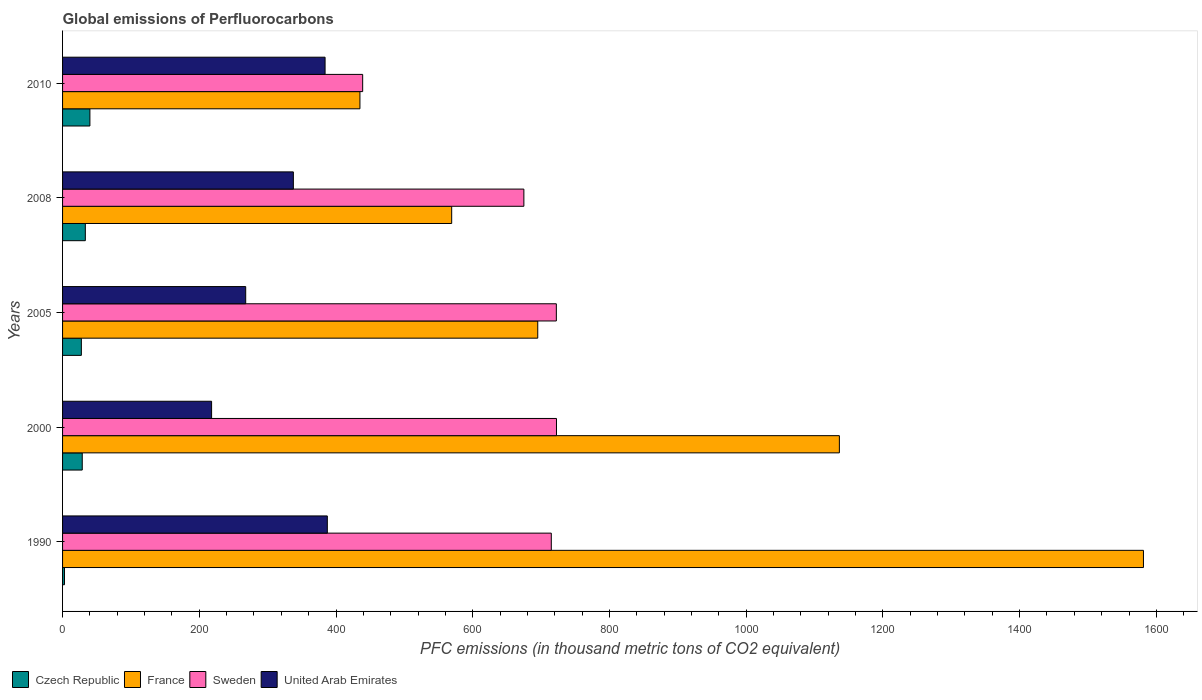How many different coloured bars are there?
Offer a very short reply. 4. How many groups of bars are there?
Give a very brief answer. 5. How many bars are there on the 4th tick from the top?
Offer a terse response. 4. What is the global emissions of Perfluorocarbons in Czech Republic in 2008?
Ensure brevity in your answer.  33.3. Across all years, what is the minimum global emissions of Perfluorocarbons in United Arab Emirates?
Your answer should be very brief. 218. What is the total global emissions of Perfluorocarbons in United Arab Emirates in the graph?
Ensure brevity in your answer.  1594.8. What is the difference between the global emissions of Perfluorocarbons in France in 1990 and that in 2005?
Offer a very short reply. 886. What is the difference between the global emissions of Perfluorocarbons in Sweden in 1990 and the global emissions of Perfluorocarbons in Czech Republic in 2005?
Your answer should be compact. 687.4. What is the average global emissions of Perfluorocarbons in Czech Republic per year?
Offer a terse response. 26.48. In the year 1990, what is the difference between the global emissions of Perfluorocarbons in Sweden and global emissions of Perfluorocarbons in Czech Republic?
Provide a short and direct response. 712.1. In how many years, is the global emissions of Perfluorocarbons in Czech Republic greater than 440 thousand metric tons?
Your answer should be very brief. 0. What is the ratio of the global emissions of Perfluorocarbons in United Arab Emirates in 2005 to that in 2008?
Your response must be concise. 0.79. Is the global emissions of Perfluorocarbons in Sweden in 1990 less than that in 2005?
Provide a succinct answer. Yes. Is the difference between the global emissions of Perfluorocarbons in Sweden in 1990 and 2000 greater than the difference between the global emissions of Perfluorocarbons in Czech Republic in 1990 and 2000?
Make the answer very short. Yes. What is the difference between the highest and the second highest global emissions of Perfluorocarbons in France?
Offer a terse response. 444.8. What is the difference between the highest and the lowest global emissions of Perfluorocarbons in United Arab Emirates?
Give a very brief answer. 169.3. Is it the case that in every year, the sum of the global emissions of Perfluorocarbons in Sweden and global emissions of Perfluorocarbons in Czech Republic is greater than the sum of global emissions of Perfluorocarbons in United Arab Emirates and global emissions of Perfluorocarbons in France?
Give a very brief answer. Yes. What does the 2nd bar from the top in 2005 represents?
Ensure brevity in your answer.  Sweden. What does the 4th bar from the bottom in 2005 represents?
Your answer should be compact. United Arab Emirates. Is it the case that in every year, the sum of the global emissions of Perfluorocarbons in Sweden and global emissions of Perfluorocarbons in United Arab Emirates is greater than the global emissions of Perfluorocarbons in France?
Keep it short and to the point. No. How many bars are there?
Keep it short and to the point. 20. Does the graph contain any zero values?
Your answer should be very brief. No. Does the graph contain grids?
Ensure brevity in your answer.  No. Where does the legend appear in the graph?
Provide a short and direct response. Bottom left. How many legend labels are there?
Your answer should be very brief. 4. How are the legend labels stacked?
Your answer should be very brief. Horizontal. What is the title of the graph?
Your response must be concise. Global emissions of Perfluorocarbons. Does "Papua New Guinea" appear as one of the legend labels in the graph?
Keep it short and to the point. No. What is the label or title of the X-axis?
Your response must be concise. PFC emissions (in thousand metric tons of CO2 equivalent). What is the PFC emissions (in thousand metric tons of CO2 equivalent) of France in 1990?
Offer a very short reply. 1581.1. What is the PFC emissions (in thousand metric tons of CO2 equivalent) of Sweden in 1990?
Ensure brevity in your answer.  714.9. What is the PFC emissions (in thousand metric tons of CO2 equivalent) in United Arab Emirates in 1990?
Your answer should be very brief. 387.3. What is the PFC emissions (in thousand metric tons of CO2 equivalent) of Czech Republic in 2000?
Offer a terse response. 28.8. What is the PFC emissions (in thousand metric tons of CO2 equivalent) in France in 2000?
Give a very brief answer. 1136.3. What is the PFC emissions (in thousand metric tons of CO2 equivalent) of Sweden in 2000?
Keep it short and to the point. 722.5. What is the PFC emissions (in thousand metric tons of CO2 equivalent) of United Arab Emirates in 2000?
Your response must be concise. 218. What is the PFC emissions (in thousand metric tons of CO2 equivalent) in France in 2005?
Offer a terse response. 695.1. What is the PFC emissions (in thousand metric tons of CO2 equivalent) in Sweden in 2005?
Offer a terse response. 722.3. What is the PFC emissions (in thousand metric tons of CO2 equivalent) of United Arab Emirates in 2005?
Your answer should be compact. 267.9. What is the PFC emissions (in thousand metric tons of CO2 equivalent) of Czech Republic in 2008?
Your answer should be compact. 33.3. What is the PFC emissions (in thousand metric tons of CO2 equivalent) in France in 2008?
Give a very brief answer. 569.2. What is the PFC emissions (in thousand metric tons of CO2 equivalent) of Sweden in 2008?
Offer a terse response. 674.8. What is the PFC emissions (in thousand metric tons of CO2 equivalent) in United Arab Emirates in 2008?
Provide a succinct answer. 337.6. What is the PFC emissions (in thousand metric tons of CO2 equivalent) in Czech Republic in 2010?
Your response must be concise. 40. What is the PFC emissions (in thousand metric tons of CO2 equivalent) of France in 2010?
Your response must be concise. 435. What is the PFC emissions (in thousand metric tons of CO2 equivalent) of Sweden in 2010?
Ensure brevity in your answer.  439. What is the PFC emissions (in thousand metric tons of CO2 equivalent) of United Arab Emirates in 2010?
Give a very brief answer. 384. Across all years, what is the maximum PFC emissions (in thousand metric tons of CO2 equivalent) of Czech Republic?
Your answer should be compact. 40. Across all years, what is the maximum PFC emissions (in thousand metric tons of CO2 equivalent) of France?
Make the answer very short. 1581.1. Across all years, what is the maximum PFC emissions (in thousand metric tons of CO2 equivalent) of Sweden?
Provide a succinct answer. 722.5. Across all years, what is the maximum PFC emissions (in thousand metric tons of CO2 equivalent) in United Arab Emirates?
Provide a succinct answer. 387.3. Across all years, what is the minimum PFC emissions (in thousand metric tons of CO2 equivalent) in Czech Republic?
Your answer should be compact. 2.8. Across all years, what is the minimum PFC emissions (in thousand metric tons of CO2 equivalent) of France?
Provide a succinct answer. 435. Across all years, what is the minimum PFC emissions (in thousand metric tons of CO2 equivalent) in Sweden?
Your response must be concise. 439. Across all years, what is the minimum PFC emissions (in thousand metric tons of CO2 equivalent) of United Arab Emirates?
Provide a short and direct response. 218. What is the total PFC emissions (in thousand metric tons of CO2 equivalent) in Czech Republic in the graph?
Your response must be concise. 132.4. What is the total PFC emissions (in thousand metric tons of CO2 equivalent) of France in the graph?
Offer a very short reply. 4416.7. What is the total PFC emissions (in thousand metric tons of CO2 equivalent) in Sweden in the graph?
Provide a short and direct response. 3273.5. What is the total PFC emissions (in thousand metric tons of CO2 equivalent) in United Arab Emirates in the graph?
Give a very brief answer. 1594.8. What is the difference between the PFC emissions (in thousand metric tons of CO2 equivalent) in Czech Republic in 1990 and that in 2000?
Provide a short and direct response. -26. What is the difference between the PFC emissions (in thousand metric tons of CO2 equivalent) of France in 1990 and that in 2000?
Offer a terse response. 444.8. What is the difference between the PFC emissions (in thousand metric tons of CO2 equivalent) of United Arab Emirates in 1990 and that in 2000?
Give a very brief answer. 169.3. What is the difference between the PFC emissions (in thousand metric tons of CO2 equivalent) of Czech Republic in 1990 and that in 2005?
Offer a terse response. -24.7. What is the difference between the PFC emissions (in thousand metric tons of CO2 equivalent) in France in 1990 and that in 2005?
Keep it short and to the point. 886. What is the difference between the PFC emissions (in thousand metric tons of CO2 equivalent) in United Arab Emirates in 1990 and that in 2005?
Your answer should be compact. 119.4. What is the difference between the PFC emissions (in thousand metric tons of CO2 equivalent) in Czech Republic in 1990 and that in 2008?
Provide a succinct answer. -30.5. What is the difference between the PFC emissions (in thousand metric tons of CO2 equivalent) of France in 1990 and that in 2008?
Your answer should be very brief. 1011.9. What is the difference between the PFC emissions (in thousand metric tons of CO2 equivalent) of Sweden in 1990 and that in 2008?
Give a very brief answer. 40.1. What is the difference between the PFC emissions (in thousand metric tons of CO2 equivalent) in United Arab Emirates in 1990 and that in 2008?
Provide a short and direct response. 49.7. What is the difference between the PFC emissions (in thousand metric tons of CO2 equivalent) of Czech Republic in 1990 and that in 2010?
Provide a short and direct response. -37.2. What is the difference between the PFC emissions (in thousand metric tons of CO2 equivalent) of France in 1990 and that in 2010?
Ensure brevity in your answer.  1146.1. What is the difference between the PFC emissions (in thousand metric tons of CO2 equivalent) of Sweden in 1990 and that in 2010?
Your answer should be compact. 275.9. What is the difference between the PFC emissions (in thousand metric tons of CO2 equivalent) of Czech Republic in 2000 and that in 2005?
Your response must be concise. 1.3. What is the difference between the PFC emissions (in thousand metric tons of CO2 equivalent) in France in 2000 and that in 2005?
Provide a short and direct response. 441.2. What is the difference between the PFC emissions (in thousand metric tons of CO2 equivalent) in United Arab Emirates in 2000 and that in 2005?
Your response must be concise. -49.9. What is the difference between the PFC emissions (in thousand metric tons of CO2 equivalent) of France in 2000 and that in 2008?
Ensure brevity in your answer.  567.1. What is the difference between the PFC emissions (in thousand metric tons of CO2 equivalent) in Sweden in 2000 and that in 2008?
Offer a terse response. 47.7. What is the difference between the PFC emissions (in thousand metric tons of CO2 equivalent) of United Arab Emirates in 2000 and that in 2008?
Your response must be concise. -119.6. What is the difference between the PFC emissions (in thousand metric tons of CO2 equivalent) in France in 2000 and that in 2010?
Ensure brevity in your answer.  701.3. What is the difference between the PFC emissions (in thousand metric tons of CO2 equivalent) of Sweden in 2000 and that in 2010?
Your answer should be very brief. 283.5. What is the difference between the PFC emissions (in thousand metric tons of CO2 equivalent) of United Arab Emirates in 2000 and that in 2010?
Make the answer very short. -166. What is the difference between the PFC emissions (in thousand metric tons of CO2 equivalent) in Czech Republic in 2005 and that in 2008?
Ensure brevity in your answer.  -5.8. What is the difference between the PFC emissions (in thousand metric tons of CO2 equivalent) in France in 2005 and that in 2008?
Keep it short and to the point. 125.9. What is the difference between the PFC emissions (in thousand metric tons of CO2 equivalent) of Sweden in 2005 and that in 2008?
Ensure brevity in your answer.  47.5. What is the difference between the PFC emissions (in thousand metric tons of CO2 equivalent) in United Arab Emirates in 2005 and that in 2008?
Your response must be concise. -69.7. What is the difference between the PFC emissions (in thousand metric tons of CO2 equivalent) in Czech Republic in 2005 and that in 2010?
Ensure brevity in your answer.  -12.5. What is the difference between the PFC emissions (in thousand metric tons of CO2 equivalent) in France in 2005 and that in 2010?
Your answer should be compact. 260.1. What is the difference between the PFC emissions (in thousand metric tons of CO2 equivalent) in Sweden in 2005 and that in 2010?
Provide a short and direct response. 283.3. What is the difference between the PFC emissions (in thousand metric tons of CO2 equivalent) of United Arab Emirates in 2005 and that in 2010?
Keep it short and to the point. -116.1. What is the difference between the PFC emissions (in thousand metric tons of CO2 equivalent) in France in 2008 and that in 2010?
Offer a very short reply. 134.2. What is the difference between the PFC emissions (in thousand metric tons of CO2 equivalent) of Sweden in 2008 and that in 2010?
Keep it short and to the point. 235.8. What is the difference between the PFC emissions (in thousand metric tons of CO2 equivalent) of United Arab Emirates in 2008 and that in 2010?
Give a very brief answer. -46.4. What is the difference between the PFC emissions (in thousand metric tons of CO2 equivalent) in Czech Republic in 1990 and the PFC emissions (in thousand metric tons of CO2 equivalent) in France in 2000?
Provide a succinct answer. -1133.5. What is the difference between the PFC emissions (in thousand metric tons of CO2 equivalent) of Czech Republic in 1990 and the PFC emissions (in thousand metric tons of CO2 equivalent) of Sweden in 2000?
Your response must be concise. -719.7. What is the difference between the PFC emissions (in thousand metric tons of CO2 equivalent) in Czech Republic in 1990 and the PFC emissions (in thousand metric tons of CO2 equivalent) in United Arab Emirates in 2000?
Give a very brief answer. -215.2. What is the difference between the PFC emissions (in thousand metric tons of CO2 equivalent) in France in 1990 and the PFC emissions (in thousand metric tons of CO2 equivalent) in Sweden in 2000?
Your response must be concise. 858.6. What is the difference between the PFC emissions (in thousand metric tons of CO2 equivalent) of France in 1990 and the PFC emissions (in thousand metric tons of CO2 equivalent) of United Arab Emirates in 2000?
Offer a very short reply. 1363.1. What is the difference between the PFC emissions (in thousand metric tons of CO2 equivalent) in Sweden in 1990 and the PFC emissions (in thousand metric tons of CO2 equivalent) in United Arab Emirates in 2000?
Give a very brief answer. 496.9. What is the difference between the PFC emissions (in thousand metric tons of CO2 equivalent) of Czech Republic in 1990 and the PFC emissions (in thousand metric tons of CO2 equivalent) of France in 2005?
Your answer should be very brief. -692.3. What is the difference between the PFC emissions (in thousand metric tons of CO2 equivalent) in Czech Republic in 1990 and the PFC emissions (in thousand metric tons of CO2 equivalent) in Sweden in 2005?
Your response must be concise. -719.5. What is the difference between the PFC emissions (in thousand metric tons of CO2 equivalent) of Czech Republic in 1990 and the PFC emissions (in thousand metric tons of CO2 equivalent) of United Arab Emirates in 2005?
Ensure brevity in your answer.  -265.1. What is the difference between the PFC emissions (in thousand metric tons of CO2 equivalent) in France in 1990 and the PFC emissions (in thousand metric tons of CO2 equivalent) in Sweden in 2005?
Your answer should be compact. 858.8. What is the difference between the PFC emissions (in thousand metric tons of CO2 equivalent) of France in 1990 and the PFC emissions (in thousand metric tons of CO2 equivalent) of United Arab Emirates in 2005?
Make the answer very short. 1313.2. What is the difference between the PFC emissions (in thousand metric tons of CO2 equivalent) of Sweden in 1990 and the PFC emissions (in thousand metric tons of CO2 equivalent) of United Arab Emirates in 2005?
Give a very brief answer. 447. What is the difference between the PFC emissions (in thousand metric tons of CO2 equivalent) of Czech Republic in 1990 and the PFC emissions (in thousand metric tons of CO2 equivalent) of France in 2008?
Keep it short and to the point. -566.4. What is the difference between the PFC emissions (in thousand metric tons of CO2 equivalent) of Czech Republic in 1990 and the PFC emissions (in thousand metric tons of CO2 equivalent) of Sweden in 2008?
Ensure brevity in your answer.  -672. What is the difference between the PFC emissions (in thousand metric tons of CO2 equivalent) of Czech Republic in 1990 and the PFC emissions (in thousand metric tons of CO2 equivalent) of United Arab Emirates in 2008?
Your answer should be very brief. -334.8. What is the difference between the PFC emissions (in thousand metric tons of CO2 equivalent) of France in 1990 and the PFC emissions (in thousand metric tons of CO2 equivalent) of Sweden in 2008?
Make the answer very short. 906.3. What is the difference between the PFC emissions (in thousand metric tons of CO2 equivalent) of France in 1990 and the PFC emissions (in thousand metric tons of CO2 equivalent) of United Arab Emirates in 2008?
Your answer should be compact. 1243.5. What is the difference between the PFC emissions (in thousand metric tons of CO2 equivalent) of Sweden in 1990 and the PFC emissions (in thousand metric tons of CO2 equivalent) of United Arab Emirates in 2008?
Keep it short and to the point. 377.3. What is the difference between the PFC emissions (in thousand metric tons of CO2 equivalent) of Czech Republic in 1990 and the PFC emissions (in thousand metric tons of CO2 equivalent) of France in 2010?
Your answer should be very brief. -432.2. What is the difference between the PFC emissions (in thousand metric tons of CO2 equivalent) of Czech Republic in 1990 and the PFC emissions (in thousand metric tons of CO2 equivalent) of Sweden in 2010?
Give a very brief answer. -436.2. What is the difference between the PFC emissions (in thousand metric tons of CO2 equivalent) of Czech Republic in 1990 and the PFC emissions (in thousand metric tons of CO2 equivalent) of United Arab Emirates in 2010?
Offer a very short reply. -381.2. What is the difference between the PFC emissions (in thousand metric tons of CO2 equivalent) of France in 1990 and the PFC emissions (in thousand metric tons of CO2 equivalent) of Sweden in 2010?
Your answer should be very brief. 1142.1. What is the difference between the PFC emissions (in thousand metric tons of CO2 equivalent) in France in 1990 and the PFC emissions (in thousand metric tons of CO2 equivalent) in United Arab Emirates in 2010?
Provide a succinct answer. 1197.1. What is the difference between the PFC emissions (in thousand metric tons of CO2 equivalent) of Sweden in 1990 and the PFC emissions (in thousand metric tons of CO2 equivalent) of United Arab Emirates in 2010?
Offer a very short reply. 330.9. What is the difference between the PFC emissions (in thousand metric tons of CO2 equivalent) in Czech Republic in 2000 and the PFC emissions (in thousand metric tons of CO2 equivalent) in France in 2005?
Give a very brief answer. -666.3. What is the difference between the PFC emissions (in thousand metric tons of CO2 equivalent) of Czech Republic in 2000 and the PFC emissions (in thousand metric tons of CO2 equivalent) of Sweden in 2005?
Give a very brief answer. -693.5. What is the difference between the PFC emissions (in thousand metric tons of CO2 equivalent) of Czech Republic in 2000 and the PFC emissions (in thousand metric tons of CO2 equivalent) of United Arab Emirates in 2005?
Offer a very short reply. -239.1. What is the difference between the PFC emissions (in thousand metric tons of CO2 equivalent) in France in 2000 and the PFC emissions (in thousand metric tons of CO2 equivalent) in Sweden in 2005?
Provide a short and direct response. 414. What is the difference between the PFC emissions (in thousand metric tons of CO2 equivalent) in France in 2000 and the PFC emissions (in thousand metric tons of CO2 equivalent) in United Arab Emirates in 2005?
Ensure brevity in your answer.  868.4. What is the difference between the PFC emissions (in thousand metric tons of CO2 equivalent) of Sweden in 2000 and the PFC emissions (in thousand metric tons of CO2 equivalent) of United Arab Emirates in 2005?
Provide a succinct answer. 454.6. What is the difference between the PFC emissions (in thousand metric tons of CO2 equivalent) in Czech Republic in 2000 and the PFC emissions (in thousand metric tons of CO2 equivalent) in France in 2008?
Offer a very short reply. -540.4. What is the difference between the PFC emissions (in thousand metric tons of CO2 equivalent) in Czech Republic in 2000 and the PFC emissions (in thousand metric tons of CO2 equivalent) in Sweden in 2008?
Your answer should be very brief. -646. What is the difference between the PFC emissions (in thousand metric tons of CO2 equivalent) in Czech Republic in 2000 and the PFC emissions (in thousand metric tons of CO2 equivalent) in United Arab Emirates in 2008?
Your response must be concise. -308.8. What is the difference between the PFC emissions (in thousand metric tons of CO2 equivalent) of France in 2000 and the PFC emissions (in thousand metric tons of CO2 equivalent) of Sweden in 2008?
Offer a terse response. 461.5. What is the difference between the PFC emissions (in thousand metric tons of CO2 equivalent) of France in 2000 and the PFC emissions (in thousand metric tons of CO2 equivalent) of United Arab Emirates in 2008?
Provide a short and direct response. 798.7. What is the difference between the PFC emissions (in thousand metric tons of CO2 equivalent) in Sweden in 2000 and the PFC emissions (in thousand metric tons of CO2 equivalent) in United Arab Emirates in 2008?
Your response must be concise. 384.9. What is the difference between the PFC emissions (in thousand metric tons of CO2 equivalent) of Czech Republic in 2000 and the PFC emissions (in thousand metric tons of CO2 equivalent) of France in 2010?
Ensure brevity in your answer.  -406.2. What is the difference between the PFC emissions (in thousand metric tons of CO2 equivalent) of Czech Republic in 2000 and the PFC emissions (in thousand metric tons of CO2 equivalent) of Sweden in 2010?
Your answer should be very brief. -410.2. What is the difference between the PFC emissions (in thousand metric tons of CO2 equivalent) of Czech Republic in 2000 and the PFC emissions (in thousand metric tons of CO2 equivalent) of United Arab Emirates in 2010?
Make the answer very short. -355.2. What is the difference between the PFC emissions (in thousand metric tons of CO2 equivalent) in France in 2000 and the PFC emissions (in thousand metric tons of CO2 equivalent) in Sweden in 2010?
Your answer should be compact. 697.3. What is the difference between the PFC emissions (in thousand metric tons of CO2 equivalent) of France in 2000 and the PFC emissions (in thousand metric tons of CO2 equivalent) of United Arab Emirates in 2010?
Your answer should be compact. 752.3. What is the difference between the PFC emissions (in thousand metric tons of CO2 equivalent) of Sweden in 2000 and the PFC emissions (in thousand metric tons of CO2 equivalent) of United Arab Emirates in 2010?
Make the answer very short. 338.5. What is the difference between the PFC emissions (in thousand metric tons of CO2 equivalent) in Czech Republic in 2005 and the PFC emissions (in thousand metric tons of CO2 equivalent) in France in 2008?
Your answer should be very brief. -541.7. What is the difference between the PFC emissions (in thousand metric tons of CO2 equivalent) in Czech Republic in 2005 and the PFC emissions (in thousand metric tons of CO2 equivalent) in Sweden in 2008?
Your answer should be very brief. -647.3. What is the difference between the PFC emissions (in thousand metric tons of CO2 equivalent) of Czech Republic in 2005 and the PFC emissions (in thousand metric tons of CO2 equivalent) of United Arab Emirates in 2008?
Offer a very short reply. -310.1. What is the difference between the PFC emissions (in thousand metric tons of CO2 equivalent) in France in 2005 and the PFC emissions (in thousand metric tons of CO2 equivalent) in Sweden in 2008?
Offer a terse response. 20.3. What is the difference between the PFC emissions (in thousand metric tons of CO2 equivalent) of France in 2005 and the PFC emissions (in thousand metric tons of CO2 equivalent) of United Arab Emirates in 2008?
Provide a short and direct response. 357.5. What is the difference between the PFC emissions (in thousand metric tons of CO2 equivalent) in Sweden in 2005 and the PFC emissions (in thousand metric tons of CO2 equivalent) in United Arab Emirates in 2008?
Ensure brevity in your answer.  384.7. What is the difference between the PFC emissions (in thousand metric tons of CO2 equivalent) of Czech Republic in 2005 and the PFC emissions (in thousand metric tons of CO2 equivalent) of France in 2010?
Keep it short and to the point. -407.5. What is the difference between the PFC emissions (in thousand metric tons of CO2 equivalent) in Czech Republic in 2005 and the PFC emissions (in thousand metric tons of CO2 equivalent) in Sweden in 2010?
Your answer should be very brief. -411.5. What is the difference between the PFC emissions (in thousand metric tons of CO2 equivalent) of Czech Republic in 2005 and the PFC emissions (in thousand metric tons of CO2 equivalent) of United Arab Emirates in 2010?
Give a very brief answer. -356.5. What is the difference between the PFC emissions (in thousand metric tons of CO2 equivalent) in France in 2005 and the PFC emissions (in thousand metric tons of CO2 equivalent) in Sweden in 2010?
Make the answer very short. 256.1. What is the difference between the PFC emissions (in thousand metric tons of CO2 equivalent) of France in 2005 and the PFC emissions (in thousand metric tons of CO2 equivalent) of United Arab Emirates in 2010?
Your response must be concise. 311.1. What is the difference between the PFC emissions (in thousand metric tons of CO2 equivalent) in Sweden in 2005 and the PFC emissions (in thousand metric tons of CO2 equivalent) in United Arab Emirates in 2010?
Give a very brief answer. 338.3. What is the difference between the PFC emissions (in thousand metric tons of CO2 equivalent) in Czech Republic in 2008 and the PFC emissions (in thousand metric tons of CO2 equivalent) in France in 2010?
Offer a terse response. -401.7. What is the difference between the PFC emissions (in thousand metric tons of CO2 equivalent) of Czech Republic in 2008 and the PFC emissions (in thousand metric tons of CO2 equivalent) of Sweden in 2010?
Ensure brevity in your answer.  -405.7. What is the difference between the PFC emissions (in thousand metric tons of CO2 equivalent) in Czech Republic in 2008 and the PFC emissions (in thousand metric tons of CO2 equivalent) in United Arab Emirates in 2010?
Your answer should be very brief. -350.7. What is the difference between the PFC emissions (in thousand metric tons of CO2 equivalent) of France in 2008 and the PFC emissions (in thousand metric tons of CO2 equivalent) of Sweden in 2010?
Your response must be concise. 130.2. What is the difference between the PFC emissions (in thousand metric tons of CO2 equivalent) of France in 2008 and the PFC emissions (in thousand metric tons of CO2 equivalent) of United Arab Emirates in 2010?
Ensure brevity in your answer.  185.2. What is the difference between the PFC emissions (in thousand metric tons of CO2 equivalent) of Sweden in 2008 and the PFC emissions (in thousand metric tons of CO2 equivalent) of United Arab Emirates in 2010?
Make the answer very short. 290.8. What is the average PFC emissions (in thousand metric tons of CO2 equivalent) of Czech Republic per year?
Keep it short and to the point. 26.48. What is the average PFC emissions (in thousand metric tons of CO2 equivalent) of France per year?
Provide a short and direct response. 883.34. What is the average PFC emissions (in thousand metric tons of CO2 equivalent) of Sweden per year?
Make the answer very short. 654.7. What is the average PFC emissions (in thousand metric tons of CO2 equivalent) in United Arab Emirates per year?
Give a very brief answer. 318.96. In the year 1990, what is the difference between the PFC emissions (in thousand metric tons of CO2 equivalent) of Czech Republic and PFC emissions (in thousand metric tons of CO2 equivalent) of France?
Your response must be concise. -1578.3. In the year 1990, what is the difference between the PFC emissions (in thousand metric tons of CO2 equivalent) of Czech Republic and PFC emissions (in thousand metric tons of CO2 equivalent) of Sweden?
Provide a short and direct response. -712.1. In the year 1990, what is the difference between the PFC emissions (in thousand metric tons of CO2 equivalent) in Czech Republic and PFC emissions (in thousand metric tons of CO2 equivalent) in United Arab Emirates?
Offer a terse response. -384.5. In the year 1990, what is the difference between the PFC emissions (in thousand metric tons of CO2 equivalent) in France and PFC emissions (in thousand metric tons of CO2 equivalent) in Sweden?
Ensure brevity in your answer.  866.2. In the year 1990, what is the difference between the PFC emissions (in thousand metric tons of CO2 equivalent) of France and PFC emissions (in thousand metric tons of CO2 equivalent) of United Arab Emirates?
Give a very brief answer. 1193.8. In the year 1990, what is the difference between the PFC emissions (in thousand metric tons of CO2 equivalent) in Sweden and PFC emissions (in thousand metric tons of CO2 equivalent) in United Arab Emirates?
Your answer should be compact. 327.6. In the year 2000, what is the difference between the PFC emissions (in thousand metric tons of CO2 equivalent) of Czech Republic and PFC emissions (in thousand metric tons of CO2 equivalent) of France?
Make the answer very short. -1107.5. In the year 2000, what is the difference between the PFC emissions (in thousand metric tons of CO2 equivalent) in Czech Republic and PFC emissions (in thousand metric tons of CO2 equivalent) in Sweden?
Provide a short and direct response. -693.7. In the year 2000, what is the difference between the PFC emissions (in thousand metric tons of CO2 equivalent) of Czech Republic and PFC emissions (in thousand metric tons of CO2 equivalent) of United Arab Emirates?
Offer a very short reply. -189.2. In the year 2000, what is the difference between the PFC emissions (in thousand metric tons of CO2 equivalent) of France and PFC emissions (in thousand metric tons of CO2 equivalent) of Sweden?
Give a very brief answer. 413.8. In the year 2000, what is the difference between the PFC emissions (in thousand metric tons of CO2 equivalent) in France and PFC emissions (in thousand metric tons of CO2 equivalent) in United Arab Emirates?
Give a very brief answer. 918.3. In the year 2000, what is the difference between the PFC emissions (in thousand metric tons of CO2 equivalent) in Sweden and PFC emissions (in thousand metric tons of CO2 equivalent) in United Arab Emirates?
Offer a terse response. 504.5. In the year 2005, what is the difference between the PFC emissions (in thousand metric tons of CO2 equivalent) of Czech Republic and PFC emissions (in thousand metric tons of CO2 equivalent) of France?
Your answer should be compact. -667.6. In the year 2005, what is the difference between the PFC emissions (in thousand metric tons of CO2 equivalent) of Czech Republic and PFC emissions (in thousand metric tons of CO2 equivalent) of Sweden?
Keep it short and to the point. -694.8. In the year 2005, what is the difference between the PFC emissions (in thousand metric tons of CO2 equivalent) in Czech Republic and PFC emissions (in thousand metric tons of CO2 equivalent) in United Arab Emirates?
Offer a very short reply. -240.4. In the year 2005, what is the difference between the PFC emissions (in thousand metric tons of CO2 equivalent) in France and PFC emissions (in thousand metric tons of CO2 equivalent) in Sweden?
Make the answer very short. -27.2. In the year 2005, what is the difference between the PFC emissions (in thousand metric tons of CO2 equivalent) of France and PFC emissions (in thousand metric tons of CO2 equivalent) of United Arab Emirates?
Make the answer very short. 427.2. In the year 2005, what is the difference between the PFC emissions (in thousand metric tons of CO2 equivalent) of Sweden and PFC emissions (in thousand metric tons of CO2 equivalent) of United Arab Emirates?
Offer a terse response. 454.4. In the year 2008, what is the difference between the PFC emissions (in thousand metric tons of CO2 equivalent) of Czech Republic and PFC emissions (in thousand metric tons of CO2 equivalent) of France?
Give a very brief answer. -535.9. In the year 2008, what is the difference between the PFC emissions (in thousand metric tons of CO2 equivalent) of Czech Republic and PFC emissions (in thousand metric tons of CO2 equivalent) of Sweden?
Keep it short and to the point. -641.5. In the year 2008, what is the difference between the PFC emissions (in thousand metric tons of CO2 equivalent) in Czech Republic and PFC emissions (in thousand metric tons of CO2 equivalent) in United Arab Emirates?
Offer a terse response. -304.3. In the year 2008, what is the difference between the PFC emissions (in thousand metric tons of CO2 equivalent) in France and PFC emissions (in thousand metric tons of CO2 equivalent) in Sweden?
Offer a very short reply. -105.6. In the year 2008, what is the difference between the PFC emissions (in thousand metric tons of CO2 equivalent) in France and PFC emissions (in thousand metric tons of CO2 equivalent) in United Arab Emirates?
Offer a terse response. 231.6. In the year 2008, what is the difference between the PFC emissions (in thousand metric tons of CO2 equivalent) in Sweden and PFC emissions (in thousand metric tons of CO2 equivalent) in United Arab Emirates?
Ensure brevity in your answer.  337.2. In the year 2010, what is the difference between the PFC emissions (in thousand metric tons of CO2 equivalent) of Czech Republic and PFC emissions (in thousand metric tons of CO2 equivalent) of France?
Your response must be concise. -395. In the year 2010, what is the difference between the PFC emissions (in thousand metric tons of CO2 equivalent) in Czech Republic and PFC emissions (in thousand metric tons of CO2 equivalent) in Sweden?
Provide a succinct answer. -399. In the year 2010, what is the difference between the PFC emissions (in thousand metric tons of CO2 equivalent) of Czech Republic and PFC emissions (in thousand metric tons of CO2 equivalent) of United Arab Emirates?
Provide a short and direct response. -344. In the year 2010, what is the difference between the PFC emissions (in thousand metric tons of CO2 equivalent) in France and PFC emissions (in thousand metric tons of CO2 equivalent) in Sweden?
Provide a succinct answer. -4. In the year 2010, what is the difference between the PFC emissions (in thousand metric tons of CO2 equivalent) in France and PFC emissions (in thousand metric tons of CO2 equivalent) in United Arab Emirates?
Your response must be concise. 51. In the year 2010, what is the difference between the PFC emissions (in thousand metric tons of CO2 equivalent) of Sweden and PFC emissions (in thousand metric tons of CO2 equivalent) of United Arab Emirates?
Provide a short and direct response. 55. What is the ratio of the PFC emissions (in thousand metric tons of CO2 equivalent) of Czech Republic in 1990 to that in 2000?
Give a very brief answer. 0.1. What is the ratio of the PFC emissions (in thousand metric tons of CO2 equivalent) of France in 1990 to that in 2000?
Offer a very short reply. 1.39. What is the ratio of the PFC emissions (in thousand metric tons of CO2 equivalent) in United Arab Emirates in 1990 to that in 2000?
Your answer should be compact. 1.78. What is the ratio of the PFC emissions (in thousand metric tons of CO2 equivalent) of Czech Republic in 1990 to that in 2005?
Your answer should be compact. 0.1. What is the ratio of the PFC emissions (in thousand metric tons of CO2 equivalent) of France in 1990 to that in 2005?
Keep it short and to the point. 2.27. What is the ratio of the PFC emissions (in thousand metric tons of CO2 equivalent) of Sweden in 1990 to that in 2005?
Offer a very short reply. 0.99. What is the ratio of the PFC emissions (in thousand metric tons of CO2 equivalent) in United Arab Emirates in 1990 to that in 2005?
Your response must be concise. 1.45. What is the ratio of the PFC emissions (in thousand metric tons of CO2 equivalent) of Czech Republic in 1990 to that in 2008?
Make the answer very short. 0.08. What is the ratio of the PFC emissions (in thousand metric tons of CO2 equivalent) of France in 1990 to that in 2008?
Offer a very short reply. 2.78. What is the ratio of the PFC emissions (in thousand metric tons of CO2 equivalent) of Sweden in 1990 to that in 2008?
Offer a terse response. 1.06. What is the ratio of the PFC emissions (in thousand metric tons of CO2 equivalent) in United Arab Emirates in 1990 to that in 2008?
Give a very brief answer. 1.15. What is the ratio of the PFC emissions (in thousand metric tons of CO2 equivalent) of Czech Republic in 1990 to that in 2010?
Your answer should be very brief. 0.07. What is the ratio of the PFC emissions (in thousand metric tons of CO2 equivalent) of France in 1990 to that in 2010?
Ensure brevity in your answer.  3.63. What is the ratio of the PFC emissions (in thousand metric tons of CO2 equivalent) in Sweden in 1990 to that in 2010?
Offer a very short reply. 1.63. What is the ratio of the PFC emissions (in thousand metric tons of CO2 equivalent) of United Arab Emirates in 1990 to that in 2010?
Give a very brief answer. 1.01. What is the ratio of the PFC emissions (in thousand metric tons of CO2 equivalent) in Czech Republic in 2000 to that in 2005?
Provide a short and direct response. 1.05. What is the ratio of the PFC emissions (in thousand metric tons of CO2 equivalent) of France in 2000 to that in 2005?
Offer a very short reply. 1.63. What is the ratio of the PFC emissions (in thousand metric tons of CO2 equivalent) of Sweden in 2000 to that in 2005?
Offer a terse response. 1. What is the ratio of the PFC emissions (in thousand metric tons of CO2 equivalent) in United Arab Emirates in 2000 to that in 2005?
Provide a short and direct response. 0.81. What is the ratio of the PFC emissions (in thousand metric tons of CO2 equivalent) of Czech Republic in 2000 to that in 2008?
Make the answer very short. 0.86. What is the ratio of the PFC emissions (in thousand metric tons of CO2 equivalent) of France in 2000 to that in 2008?
Offer a terse response. 2. What is the ratio of the PFC emissions (in thousand metric tons of CO2 equivalent) of Sweden in 2000 to that in 2008?
Provide a short and direct response. 1.07. What is the ratio of the PFC emissions (in thousand metric tons of CO2 equivalent) in United Arab Emirates in 2000 to that in 2008?
Ensure brevity in your answer.  0.65. What is the ratio of the PFC emissions (in thousand metric tons of CO2 equivalent) of Czech Republic in 2000 to that in 2010?
Provide a short and direct response. 0.72. What is the ratio of the PFC emissions (in thousand metric tons of CO2 equivalent) in France in 2000 to that in 2010?
Make the answer very short. 2.61. What is the ratio of the PFC emissions (in thousand metric tons of CO2 equivalent) of Sweden in 2000 to that in 2010?
Your answer should be compact. 1.65. What is the ratio of the PFC emissions (in thousand metric tons of CO2 equivalent) of United Arab Emirates in 2000 to that in 2010?
Provide a short and direct response. 0.57. What is the ratio of the PFC emissions (in thousand metric tons of CO2 equivalent) in Czech Republic in 2005 to that in 2008?
Ensure brevity in your answer.  0.83. What is the ratio of the PFC emissions (in thousand metric tons of CO2 equivalent) in France in 2005 to that in 2008?
Make the answer very short. 1.22. What is the ratio of the PFC emissions (in thousand metric tons of CO2 equivalent) in Sweden in 2005 to that in 2008?
Your response must be concise. 1.07. What is the ratio of the PFC emissions (in thousand metric tons of CO2 equivalent) of United Arab Emirates in 2005 to that in 2008?
Make the answer very short. 0.79. What is the ratio of the PFC emissions (in thousand metric tons of CO2 equivalent) of Czech Republic in 2005 to that in 2010?
Provide a short and direct response. 0.69. What is the ratio of the PFC emissions (in thousand metric tons of CO2 equivalent) in France in 2005 to that in 2010?
Your response must be concise. 1.6. What is the ratio of the PFC emissions (in thousand metric tons of CO2 equivalent) in Sweden in 2005 to that in 2010?
Ensure brevity in your answer.  1.65. What is the ratio of the PFC emissions (in thousand metric tons of CO2 equivalent) in United Arab Emirates in 2005 to that in 2010?
Ensure brevity in your answer.  0.7. What is the ratio of the PFC emissions (in thousand metric tons of CO2 equivalent) in Czech Republic in 2008 to that in 2010?
Give a very brief answer. 0.83. What is the ratio of the PFC emissions (in thousand metric tons of CO2 equivalent) in France in 2008 to that in 2010?
Provide a short and direct response. 1.31. What is the ratio of the PFC emissions (in thousand metric tons of CO2 equivalent) in Sweden in 2008 to that in 2010?
Keep it short and to the point. 1.54. What is the ratio of the PFC emissions (in thousand metric tons of CO2 equivalent) in United Arab Emirates in 2008 to that in 2010?
Ensure brevity in your answer.  0.88. What is the difference between the highest and the second highest PFC emissions (in thousand metric tons of CO2 equivalent) of France?
Keep it short and to the point. 444.8. What is the difference between the highest and the second highest PFC emissions (in thousand metric tons of CO2 equivalent) in Sweden?
Your response must be concise. 0.2. What is the difference between the highest and the lowest PFC emissions (in thousand metric tons of CO2 equivalent) in Czech Republic?
Your answer should be compact. 37.2. What is the difference between the highest and the lowest PFC emissions (in thousand metric tons of CO2 equivalent) in France?
Provide a succinct answer. 1146.1. What is the difference between the highest and the lowest PFC emissions (in thousand metric tons of CO2 equivalent) in Sweden?
Ensure brevity in your answer.  283.5. What is the difference between the highest and the lowest PFC emissions (in thousand metric tons of CO2 equivalent) in United Arab Emirates?
Offer a very short reply. 169.3. 